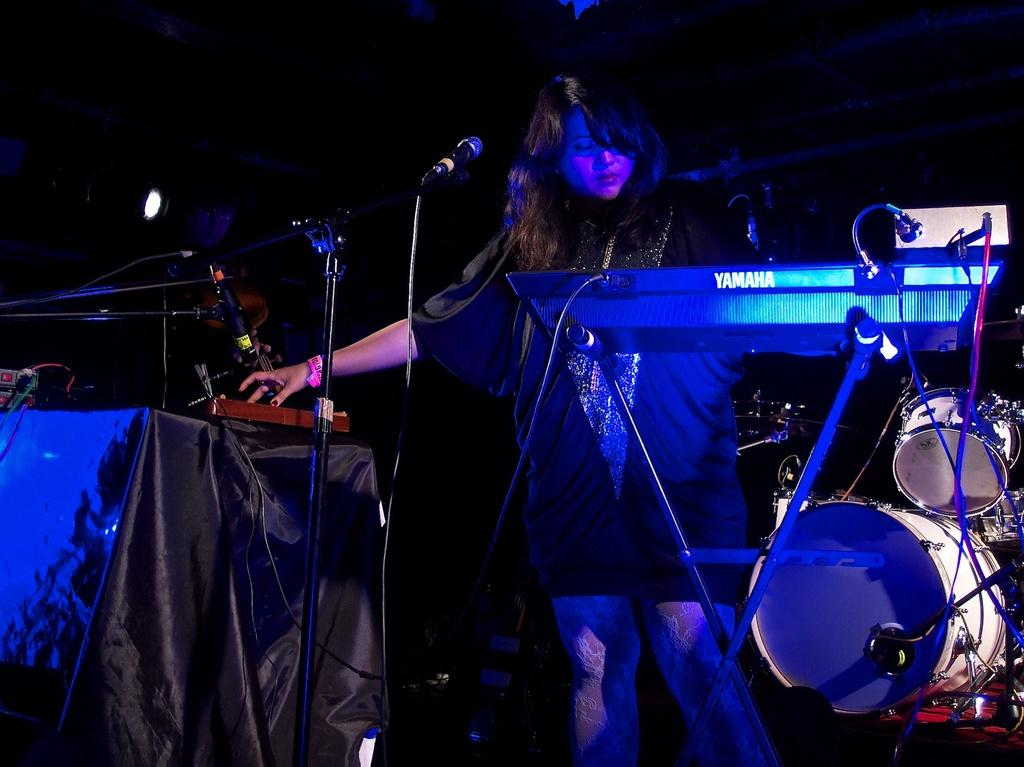What type of objects can be seen in the image related to music? There are musical instruments and microphones (mics) in the image. What material is present in the image that might be used for decoration or covering? There is cloth in the image. What electronic devices can be seen in the image? There are devices in the image. What type of equipment is used to illuminate the scene in the image? There is lighting in the image. Can you describe the woman standing in the image? There is a woman standing in the image. What is the color of the background in the image? The background of the image is dark. What type of chain can be seen around the woman's neck in the image? There is no chain visible around the woman's neck in the image. What type of map is present in the image? There is no map present in the image. 